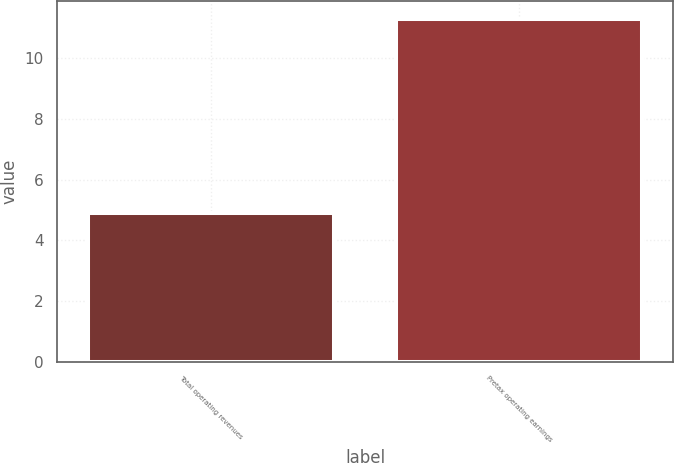Convert chart to OTSL. <chart><loc_0><loc_0><loc_500><loc_500><bar_chart><fcel>Total operating revenues<fcel>Pretax operating earnings<nl><fcel>4.9<fcel>11.3<nl></chart> 